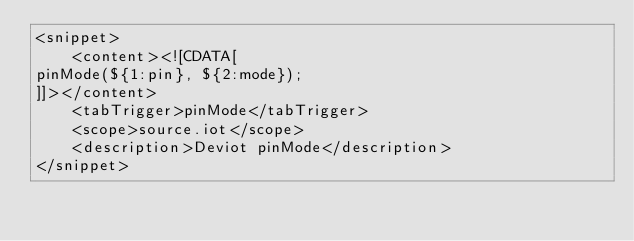<code> <loc_0><loc_0><loc_500><loc_500><_XML_><snippet>
    <content><![CDATA[
pinMode(${1:pin}, ${2:mode});
]]></content>
    <tabTrigger>pinMode</tabTrigger>
    <scope>source.iot</scope>
    <description>Deviot pinMode</description>
</snippet>
</code> 